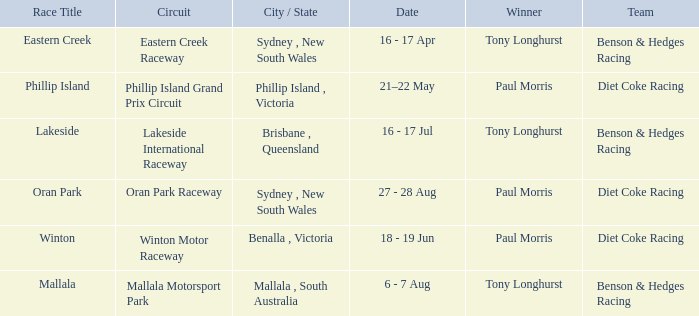What was the name of the driver that won the Lakeside race? Tony Longhurst. 